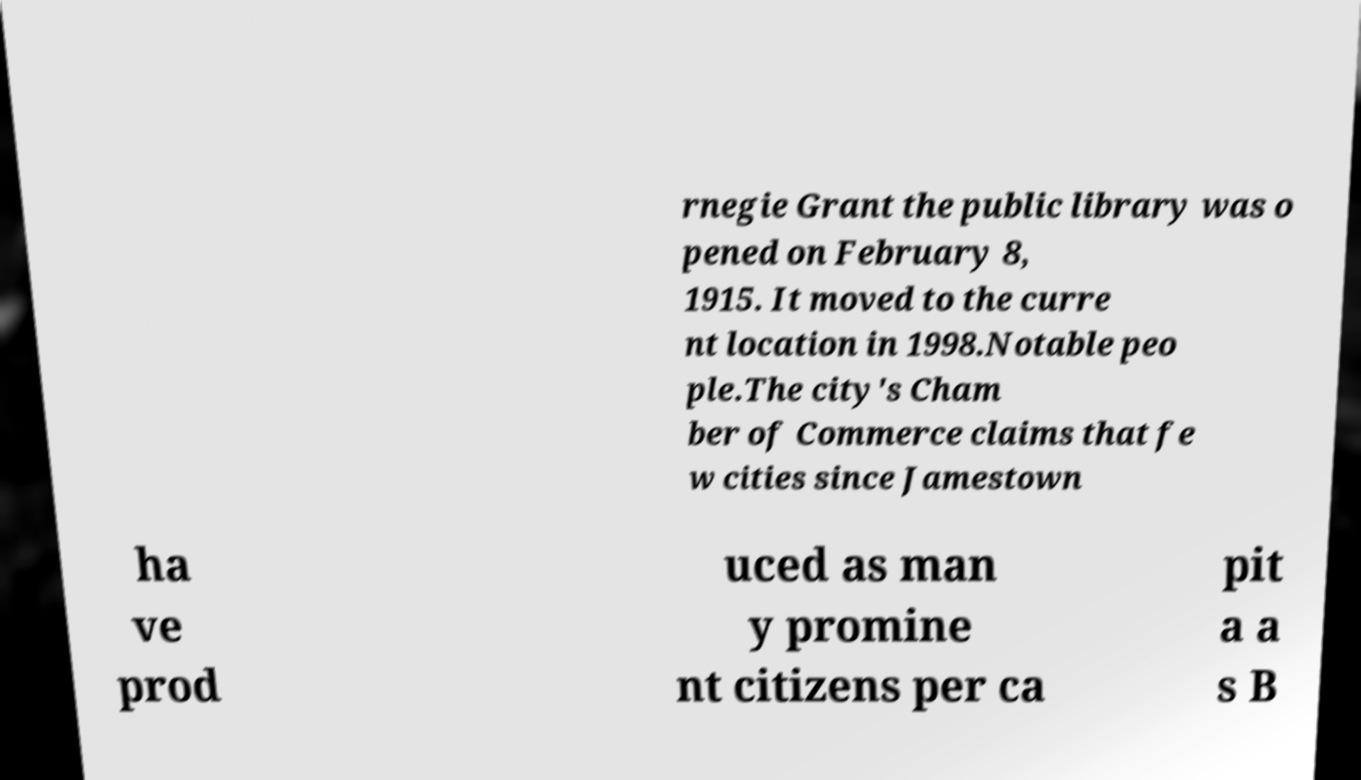Can you read and provide the text displayed in the image?This photo seems to have some interesting text. Can you extract and type it out for me? rnegie Grant the public library was o pened on February 8, 1915. It moved to the curre nt location in 1998.Notable peo ple.The city's Cham ber of Commerce claims that fe w cities since Jamestown ha ve prod uced as man y promine nt citizens per ca pit a a s B 